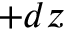<formula> <loc_0><loc_0><loc_500><loc_500>+ d z</formula> 